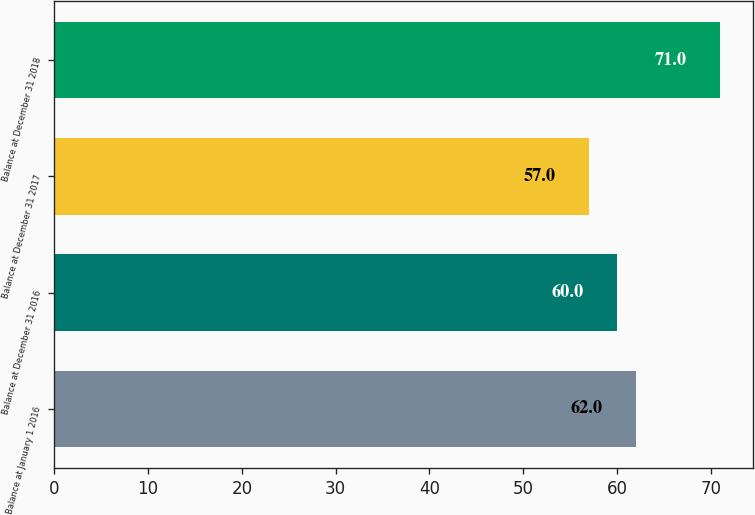Convert chart. <chart><loc_0><loc_0><loc_500><loc_500><bar_chart><fcel>Balance at January 1 2016<fcel>Balance at December 31 2016<fcel>Balance at December 31 2017<fcel>Balance at December 31 2018<nl><fcel>62<fcel>60<fcel>57<fcel>71<nl></chart> 